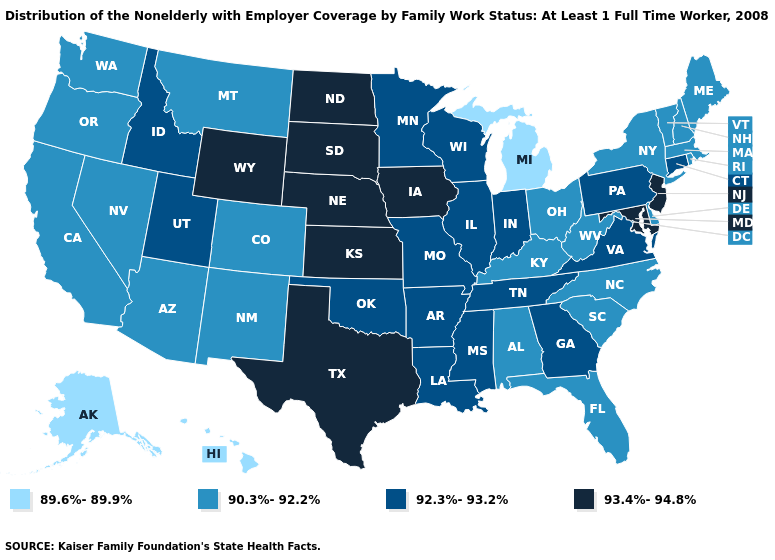What is the lowest value in the USA?
Keep it brief. 89.6%-89.9%. How many symbols are there in the legend?
Concise answer only. 4. What is the value of New Hampshire?
Quick response, please. 90.3%-92.2%. Name the states that have a value in the range 93.4%-94.8%?
Give a very brief answer. Iowa, Kansas, Maryland, Nebraska, New Jersey, North Dakota, South Dakota, Texas, Wyoming. Name the states that have a value in the range 89.6%-89.9%?
Give a very brief answer. Alaska, Hawaii, Michigan. Does South Dakota have the highest value in the MidWest?
Quick response, please. Yes. Name the states that have a value in the range 92.3%-93.2%?
Answer briefly. Arkansas, Connecticut, Georgia, Idaho, Illinois, Indiana, Louisiana, Minnesota, Mississippi, Missouri, Oklahoma, Pennsylvania, Tennessee, Utah, Virginia, Wisconsin. Among the states that border North Dakota , does Minnesota have the lowest value?
Keep it brief. No. How many symbols are there in the legend?
Quick response, please. 4. What is the highest value in states that border Louisiana?
Answer briefly. 93.4%-94.8%. Does West Virginia have the highest value in the USA?
Quick response, please. No. Which states have the highest value in the USA?
Give a very brief answer. Iowa, Kansas, Maryland, Nebraska, New Jersey, North Dakota, South Dakota, Texas, Wyoming. Does the first symbol in the legend represent the smallest category?
Answer briefly. Yes. What is the lowest value in the USA?
Be succinct. 89.6%-89.9%. 